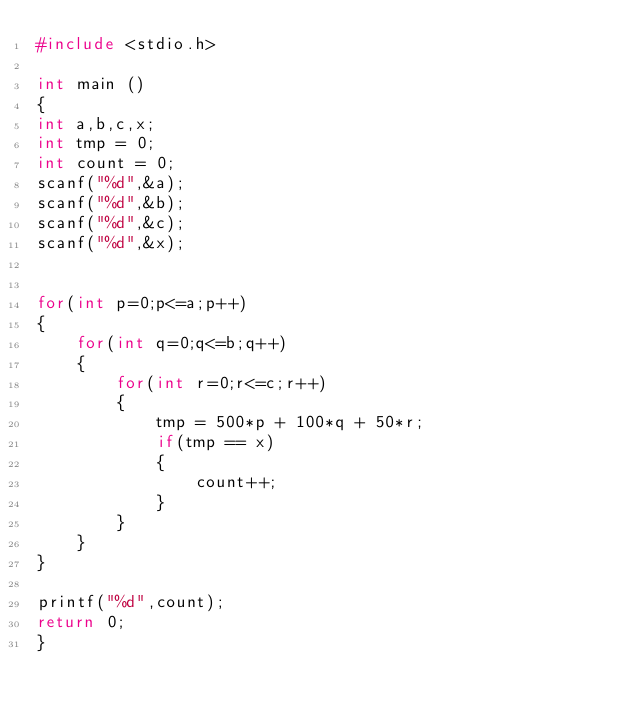Convert code to text. <code><loc_0><loc_0><loc_500><loc_500><_C_>#include <stdio.h>
 
int main () 
{
int a,b,c,x;
int tmp = 0;
int count = 0;
scanf("%d",&a);
scanf("%d",&b);
scanf("%d",&c);
scanf("%d",&x);


for(int p=0;p<=a;p++)
{
    for(int q=0;q<=b;q++)
    {
        for(int r=0;r<=c;r++)
        {
            tmp = 500*p + 100*q + 50*r;
            if(tmp == x)
            {
                count++;
            } 
        }
    }
}

printf("%d",count);
return 0;
}</code> 